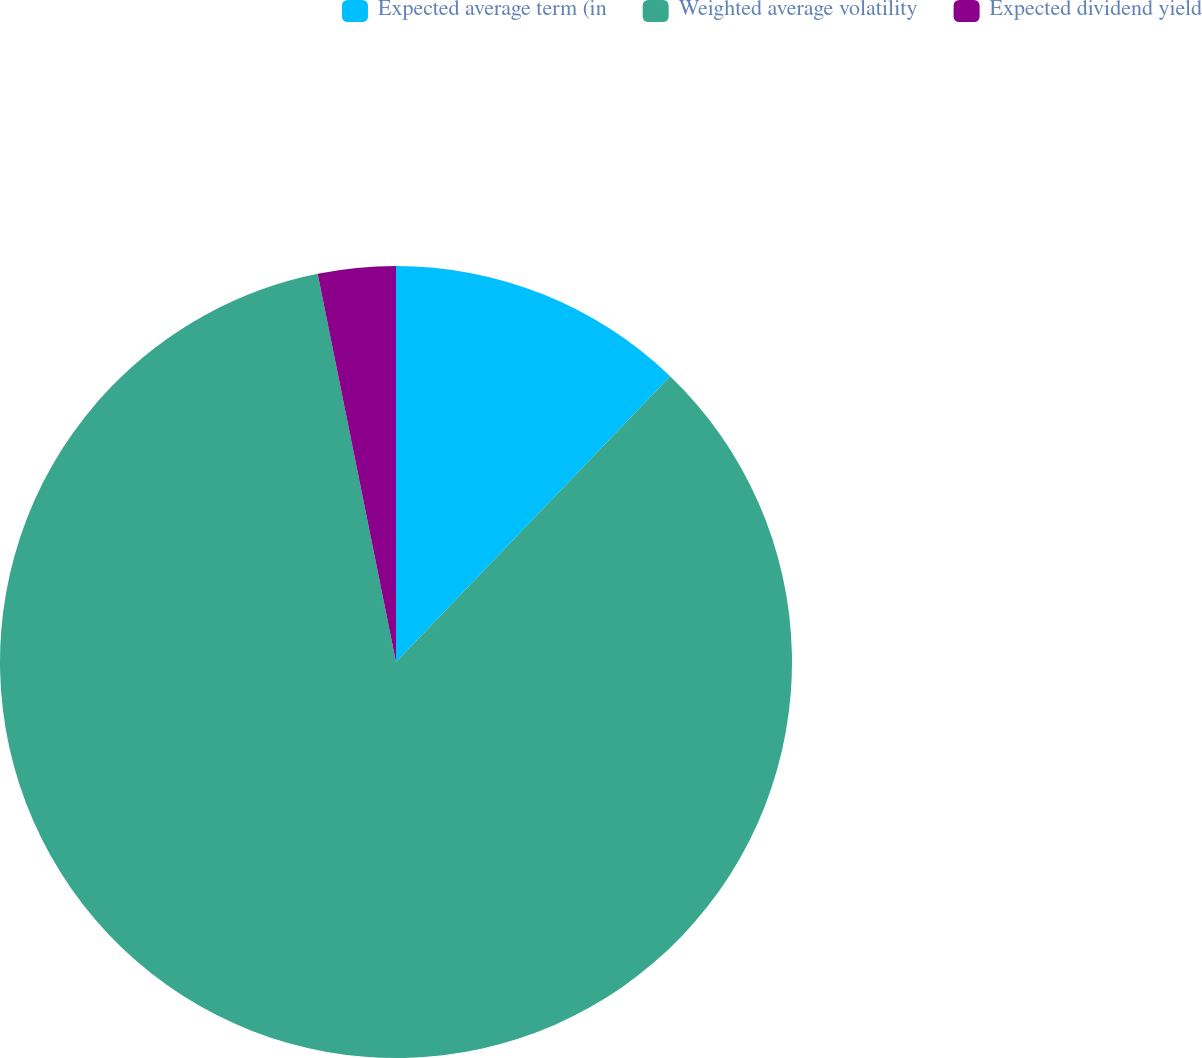Convert chart to OTSL. <chart><loc_0><loc_0><loc_500><loc_500><pie_chart><fcel>Expected average term (in<fcel>Weighted average volatility<fcel>Expected dividend yield<nl><fcel>12.17%<fcel>84.66%<fcel>3.17%<nl></chart> 